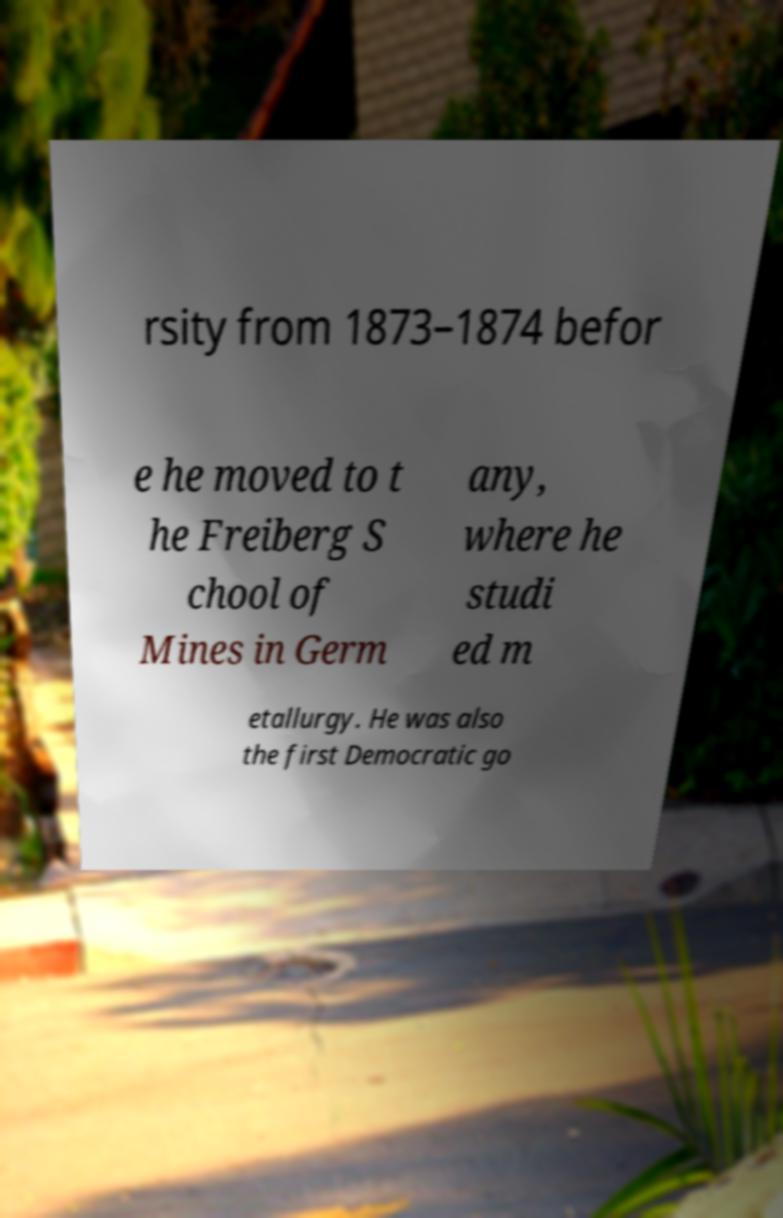Please identify and transcribe the text found in this image. rsity from 1873–1874 befor e he moved to t he Freiberg S chool of Mines in Germ any, where he studi ed m etallurgy. He was also the first Democratic go 